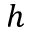Convert formula to latex. <formula><loc_0><loc_0><loc_500><loc_500>h</formula> 